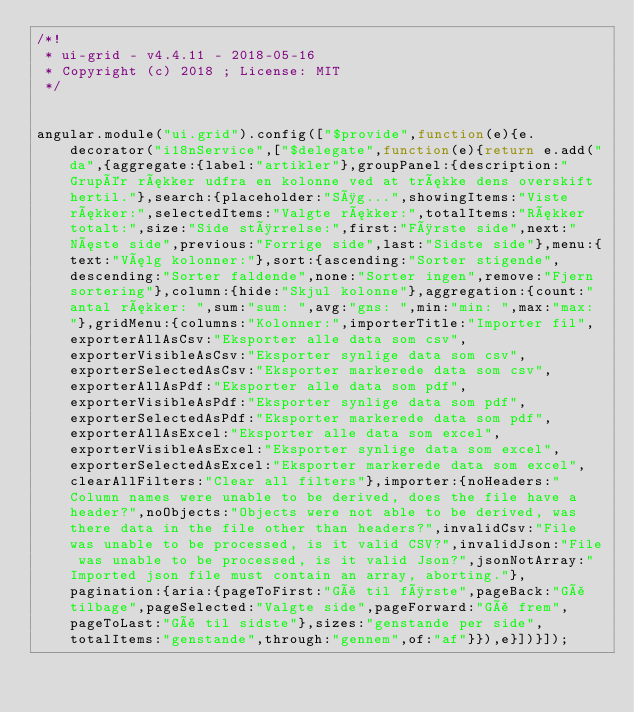<code> <loc_0><loc_0><loc_500><loc_500><_JavaScript_>/*!
 * ui-grid - v4.4.11 - 2018-05-16
 * Copyright (c) 2018 ; License: MIT 
 */


angular.module("ui.grid").config(["$provide",function(e){e.decorator("i18nService",["$delegate",function(e){return e.add("da",{aggregate:{label:"artikler"},groupPanel:{description:"Grupér rækker udfra en kolonne ved at trække dens overskift hertil."},search:{placeholder:"Søg...",showingItems:"Viste rækker:",selectedItems:"Valgte rækker:",totalItems:"Rækker totalt:",size:"Side størrelse:",first:"Første side",next:"Næste side",previous:"Forrige side",last:"Sidste side"},menu:{text:"Vælg kolonner:"},sort:{ascending:"Sorter stigende",descending:"Sorter faldende",none:"Sorter ingen",remove:"Fjern sortering"},column:{hide:"Skjul kolonne"},aggregation:{count:"antal rækker: ",sum:"sum: ",avg:"gns: ",min:"min: ",max:"max: "},gridMenu:{columns:"Kolonner:",importerTitle:"Importer fil",exporterAllAsCsv:"Eksporter alle data som csv",exporterVisibleAsCsv:"Eksporter synlige data som csv",exporterSelectedAsCsv:"Eksporter markerede data som csv",exporterAllAsPdf:"Eksporter alle data som pdf",exporterVisibleAsPdf:"Eksporter synlige data som pdf",exporterSelectedAsPdf:"Eksporter markerede data som pdf",exporterAllAsExcel:"Eksporter alle data som excel",exporterVisibleAsExcel:"Eksporter synlige data som excel",exporterSelectedAsExcel:"Eksporter markerede data som excel",clearAllFilters:"Clear all filters"},importer:{noHeaders:"Column names were unable to be derived, does the file have a header?",noObjects:"Objects were not able to be derived, was there data in the file other than headers?",invalidCsv:"File was unable to be processed, is it valid CSV?",invalidJson:"File was unable to be processed, is it valid Json?",jsonNotArray:"Imported json file must contain an array, aborting."},pagination:{aria:{pageToFirst:"Gå til første",pageBack:"Gå tilbage",pageSelected:"Valgte side",pageForward:"Gå frem",pageToLast:"Gå til sidste"},sizes:"genstande per side",totalItems:"genstande",through:"gennem",of:"af"}}),e}])}]);</code> 